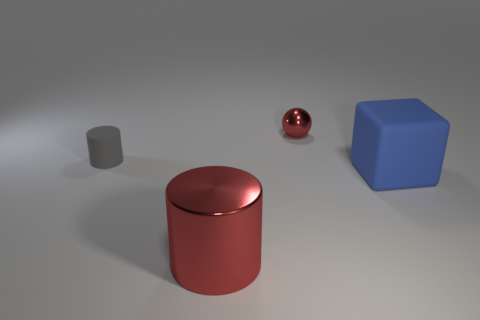Subtract all yellow cubes. Subtract all yellow cylinders. How many cubes are left? 1 Add 4 big yellow cylinders. How many objects exist? 8 Subtract all spheres. How many objects are left? 3 Subtract all rubber cylinders. Subtract all balls. How many objects are left? 2 Add 1 gray rubber objects. How many gray rubber objects are left? 2 Add 4 tiny balls. How many tiny balls exist? 5 Subtract 0 gray cubes. How many objects are left? 4 